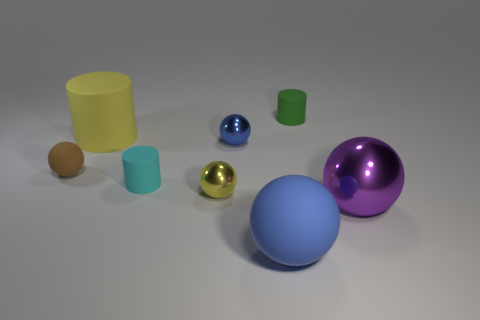Subtract all purple spheres. How many spheres are left? 4 Subtract all purple metal spheres. How many spheres are left? 4 Subtract all gray balls. Subtract all red blocks. How many balls are left? 5 Add 1 yellow matte things. How many objects exist? 9 Subtract all cylinders. How many objects are left? 5 Subtract 1 blue spheres. How many objects are left? 7 Subtract all green shiny cylinders. Subtract all large purple objects. How many objects are left? 7 Add 3 small brown things. How many small brown things are left? 4 Add 3 yellow matte things. How many yellow matte things exist? 4 